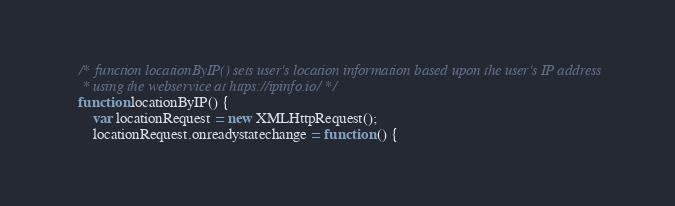Convert code to text. <code><loc_0><loc_0><loc_500><loc_500><_JavaScript_>    /* function locationByIP() sets user's location information based upon the user's IP address
     * using the webservice at https://ipinfo.io/ */
    function locationByIP() {
        var locationRequest = new XMLHttpRequest();
        locationRequest.onreadystatechange = function () {</code> 